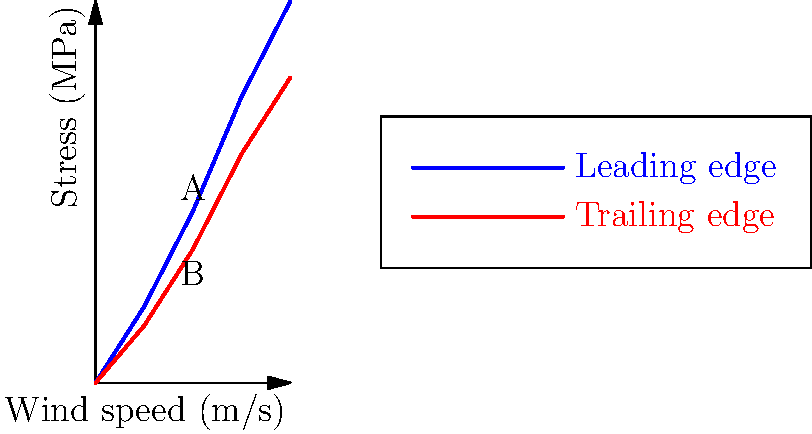The graph shows the stress distribution in a drone wing under different wind conditions. At a wind speed of 10 m/s, what is the difference in stress between the leading edge (point A) and trailing edge (point B) of the wing? To find the difference in stress between the leading edge and trailing edge at a wind speed of 10 m/s, we need to follow these steps:

1. Identify the stress values at 10 m/s:
   - Leading edge (point A): 45 MPa
   - Trailing edge (point B): 35 MPa

2. Calculate the difference:
   $\text{Stress difference} = \text{Leading edge stress} - \text{Trailing edge stress}$
   $\text{Stress difference} = 45 \text{ MPa} - 35 \text{ MPa} = 10 \text{ MPa}$

The stress difference between the leading edge and trailing edge at a wind speed of 10 m/s is 10 MPa.
Answer: 10 MPa 